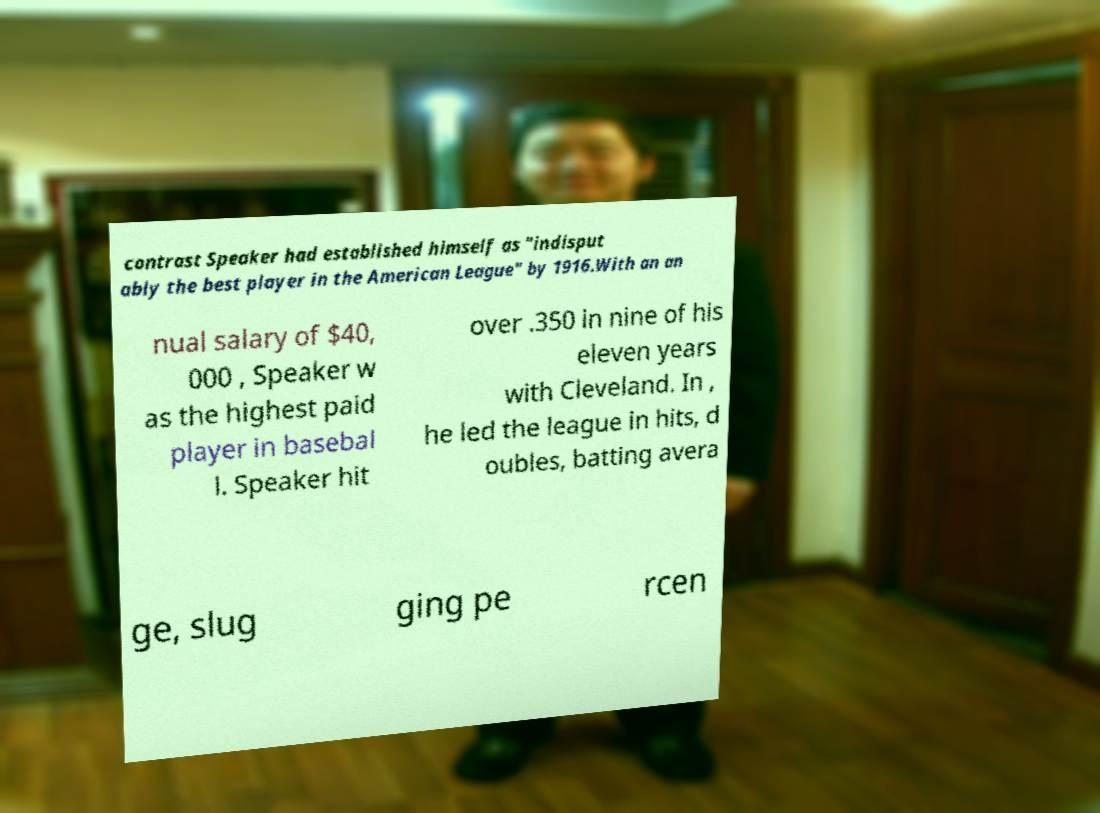Can you read and provide the text displayed in the image?This photo seems to have some interesting text. Can you extract and type it out for me? contrast Speaker had established himself as "indisput ably the best player in the American League" by 1916.With an an nual salary of $40, 000 , Speaker w as the highest paid player in basebal l. Speaker hit over .350 in nine of his eleven years with Cleveland. In , he led the league in hits, d oubles, batting avera ge, slug ging pe rcen 